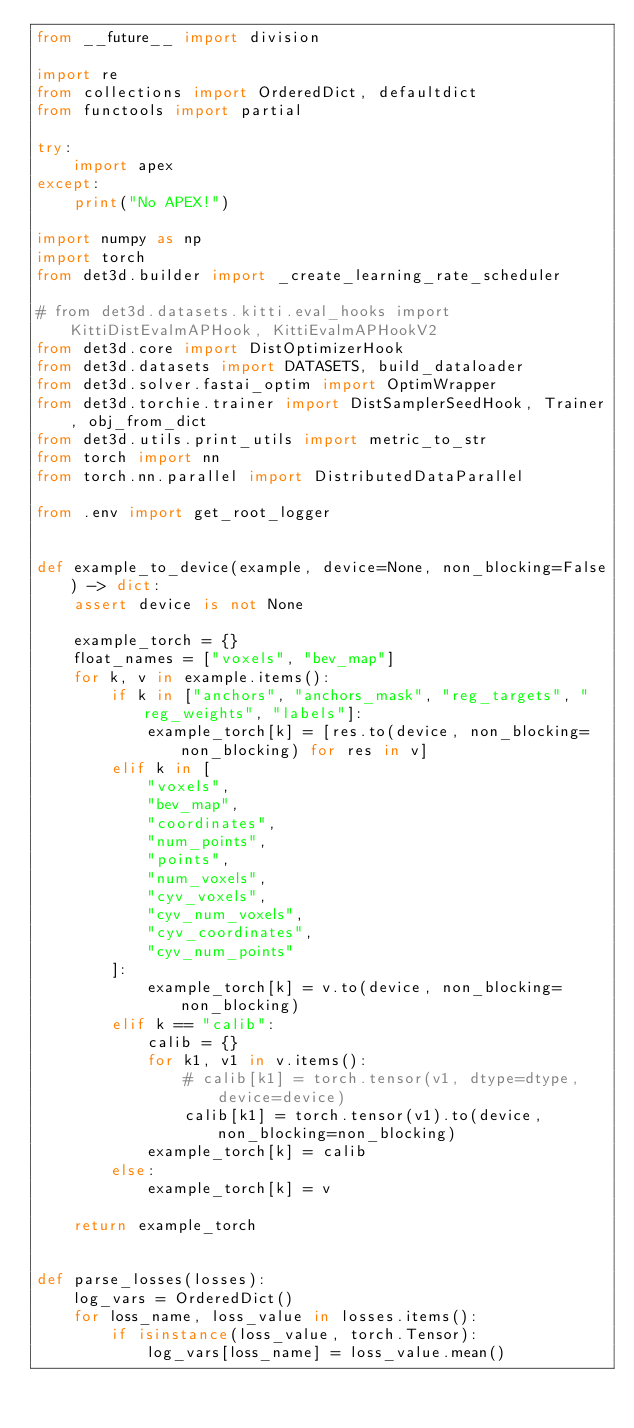Convert code to text. <code><loc_0><loc_0><loc_500><loc_500><_Python_>from __future__ import division

import re
from collections import OrderedDict, defaultdict
from functools import partial

try:
    import apex
except:
    print("No APEX!")

import numpy as np
import torch
from det3d.builder import _create_learning_rate_scheduler

# from det3d.datasets.kitti.eval_hooks import KittiDistEvalmAPHook, KittiEvalmAPHookV2
from det3d.core import DistOptimizerHook
from det3d.datasets import DATASETS, build_dataloader
from det3d.solver.fastai_optim import OptimWrapper
from det3d.torchie.trainer import DistSamplerSeedHook, Trainer, obj_from_dict
from det3d.utils.print_utils import metric_to_str
from torch import nn
from torch.nn.parallel import DistributedDataParallel

from .env import get_root_logger


def example_to_device(example, device=None, non_blocking=False) -> dict:
    assert device is not None

    example_torch = {}
    float_names = ["voxels", "bev_map"]
    for k, v in example.items():
        if k in ["anchors", "anchors_mask", "reg_targets", "reg_weights", "labels"]:
            example_torch[k] = [res.to(device, non_blocking=non_blocking) for res in v]
        elif k in [
            "voxels",
            "bev_map",
            "coordinates",
            "num_points",
            "points",
            "num_voxels",
            "cyv_voxels",
            "cyv_num_voxels",
            "cyv_coordinates",
            "cyv_num_points"
        ]:
            example_torch[k] = v.to(device, non_blocking=non_blocking)
        elif k == "calib":
            calib = {}
            for k1, v1 in v.items():
                # calib[k1] = torch.tensor(v1, dtype=dtype, device=device)
                calib[k1] = torch.tensor(v1).to(device, non_blocking=non_blocking)
            example_torch[k] = calib
        else:
            example_torch[k] = v

    return example_torch


def parse_losses(losses):
    log_vars = OrderedDict()
    for loss_name, loss_value in losses.items():
        if isinstance(loss_value, torch.Tensor):
            log_vars[loss_name] = loss_value.mean()</code> 